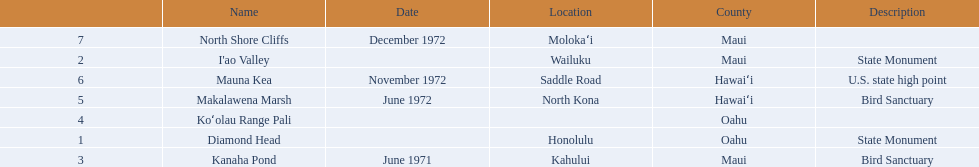What are all of the landmark names in hawaii? Diamond Head, I'ao Valley, Kanaha Pond, Koʻolau Range Pali, Makalawena Marsh, Mauna Kea, North Shore Cliffs. What are their descriptions? State Monument, State Monument, Bird Sanctuary, , Bird Sanctuary, U.S. state high point, . And which is described as a u.s. state high point? Mauna Kea. 